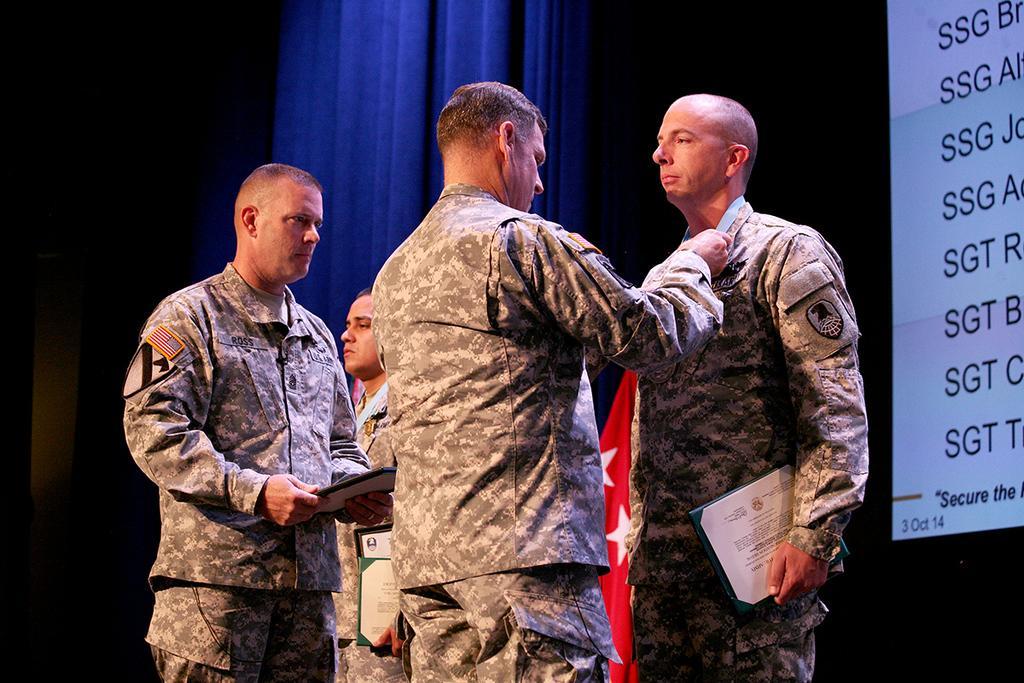Please provide a concise description of this image. In this image we can see the four persons standing and holding the objects, also we can see the curtains, flag and a screen with some text. 